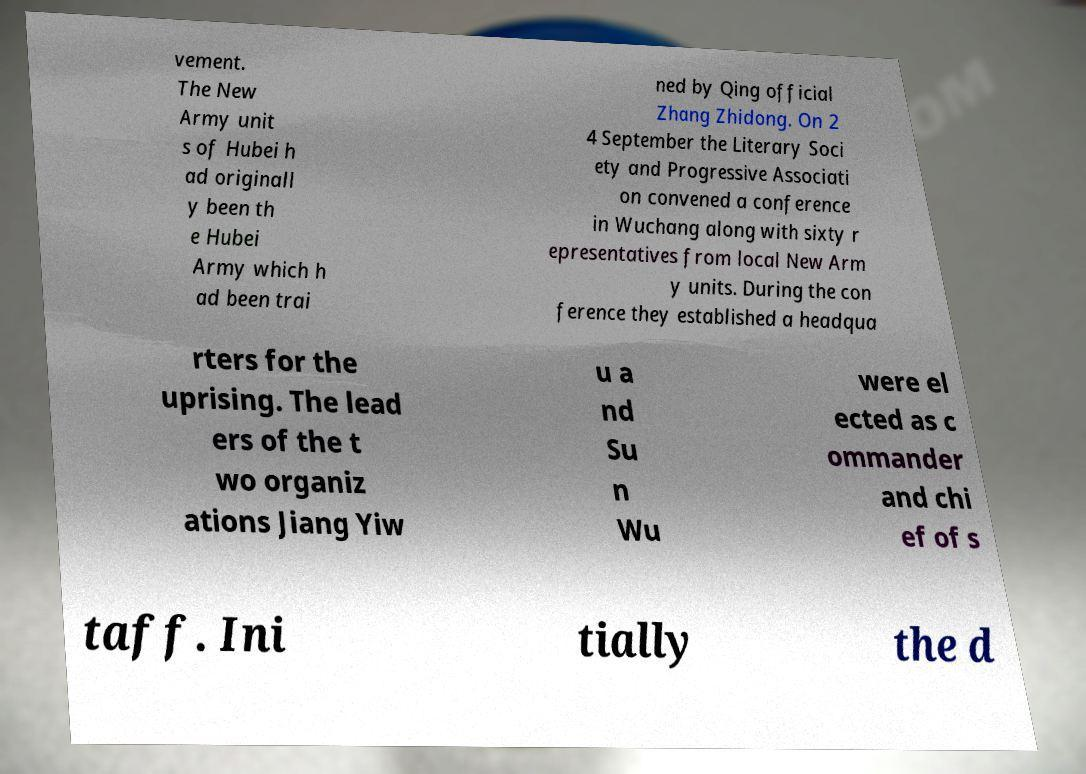Can you accurately transcribe the text from the provided image for me? vement. The New Army unit s of Hubei h ad originall y been th e Hubei Army which h ad been trai ned by Qing official Zhang Zhidong. On 2 4 September the Literary Soci ety and Progressive Associati on convened a conference in Wuchang along with sixty r epresentatives from local New Arm y units. During the con ference they established a headqua rters for the uprising. The lead ers of the t wo organiz ations Jiang Yiw u a nd Su n Wu were el ected as c ommander and chi ef of s taff. Ini tially the d 